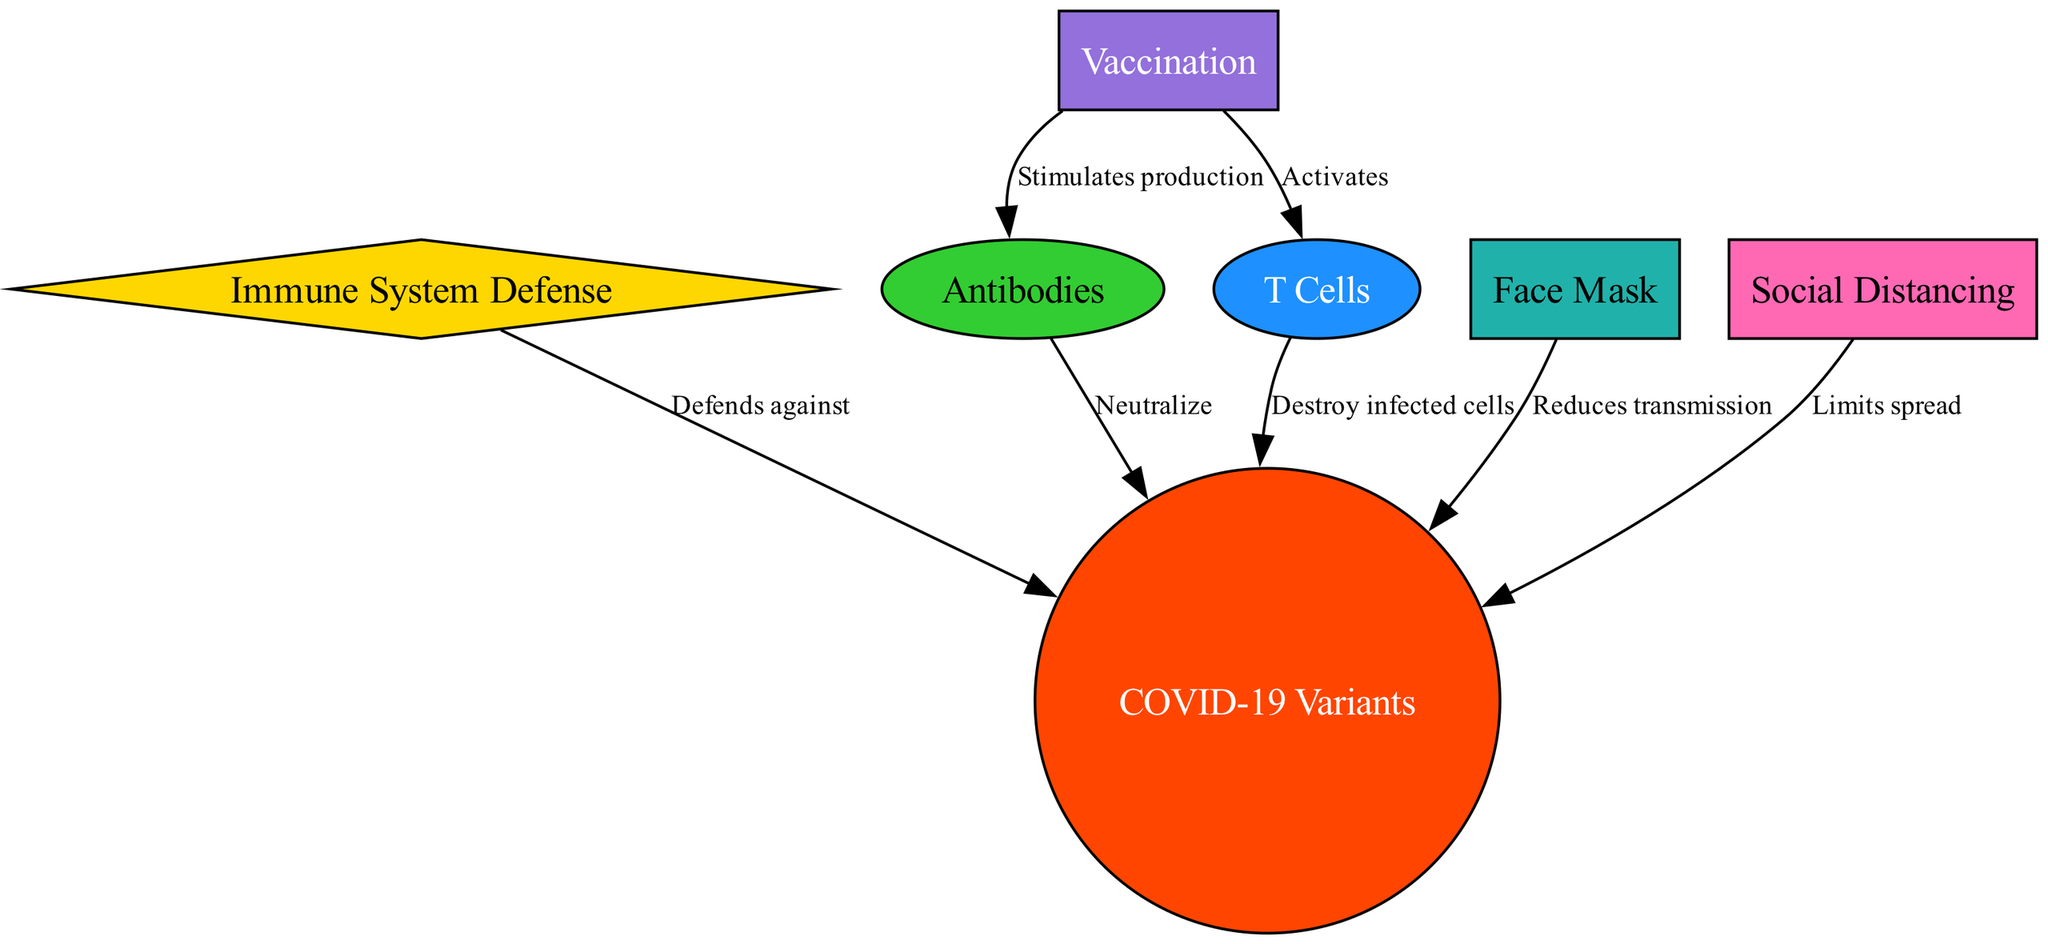What does the immune system defend against? The diagram shows that the immune system's primary defense target is COVID-19 variants. This information is explicitly stated in the edge connecting the "Immune System Defense" node to the "COVID-19 Variants" node.
Answer: COVID-19 Variants How many nodes are in the diagram? Counting all unique nodes listed in the diagram, there are seven nodes: immune system, COVID-19 variants, antibodies, T cells, vaccination, mask, and social distancing. Therefore, the total number is seven.
Answer: 7 What do antibodies do? The diagram indicates that antibodies "neutralize" COVID-19 variants, as shown by the connection from the "Antibodies" node to the "COVID-19 Variants" node with the label "Neutralize."
Answer: Neutralize Which node stimulates the production of antibodies? According to the diagram, the "Vaccination" node is the source that stimulates the production of antibodies, as indicated by the edge labeled "Stimulates production" connecting "Vaccination" to "Antibodies."
Answer: Vaccination What actions do T cells perform against COVID-19? The diagram highlights that T cells "destroy infected cells" when responding to COVID-19 variants. This is illustrated by the edge from the "T Cells" node to the "COVID-19 Variants" node with the label "Destroy infected cells."
Answer: Destroy infected cells How does the use of masks impact COVID-19 transmission? The diagram shows that masks help in "reducing transmission." This connection is depicted by the edge leading from the "Face Mask" node to the "COVID-19 Variants" node, emphasizing the preventive measure's effect on the virus's spread.
Answer: Reduces transmission What two immune responses does vaccination activate? The diagram indicates that vaccination activates both antibodies and T cells. This is shown by two edges from the "Vaccination" node: one labeled "Stimulates production" connecting to "Antibodies" and another labeled "Activates" connecting to "T Cells."
Answer: Antibodies, T Cells What is the role of social distancing? The diagram states that social distancing "limits spread," which is shown by an edge connecting the "Social Distancing" node to the "COVID-19 Variants" node labeled "Limits spread."
Answer: Limits spread Which node's action reduces transmission besides vaccination? Beyond vaccination, the “Face Mask” node also reduces COVID-19 transmission as indicated by the direct edge labeled "Reduces transmission" from the "Face Mask" node to the "COVID-19 Variants" node.
Answer: Face Mask 